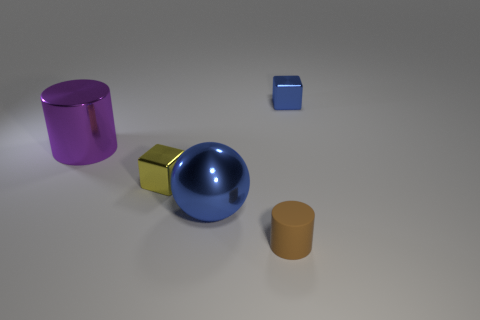What could be the function of the purple cylinder? The purple cylinder, based on its appearance in the image, might be a simple container or a decorative piece due to its size and shape. Without further context, it's difficult to determine its specific function. 